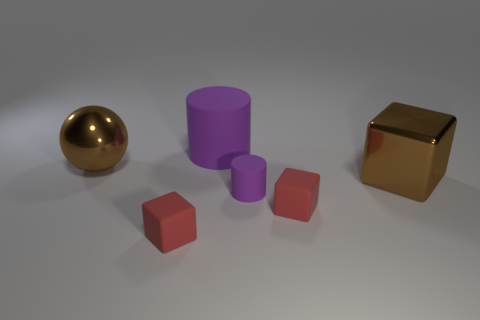Is there a object made of the same material as the large block?
Provide a succinct answer. Yes. The rubber object that is both left of the tiny cylinder and in front of the big rubber cylinder has what shape?
Ensure brevity in your answer.  Cube. How many other things are there of the same shape as the tiny purple rubber thing?
Provide a succinct answer. 1. What number of things are large things or big cyan matte things?
Provide a short and direct response. 3. There is a purple thing in front of the large shiny ball; how big is it?
Give a very brief answer. Small. The cube that is both to the right of the small purple matte cylinder and in front of the small matte cylinder is what color?
Your answer should be compact. Red. Do the tiny cube left of the big purple thing and the large cylinder have the same material?
Your response must be concise. Yes. There is a shiny sphere; is its color the same as the big shiny object in front of the metal ball?
Give a very brief answer. Yes. Are there any small red matte objects to the left of the big rubber cylinder?
Your answer should be compact. Yes. There is a red matte block that is on the right side of the big rubber object; is its size the same as the red matte object that is left of the tiny purple rubber cylinder?
Ensure brevity in your answer.  Yes. 